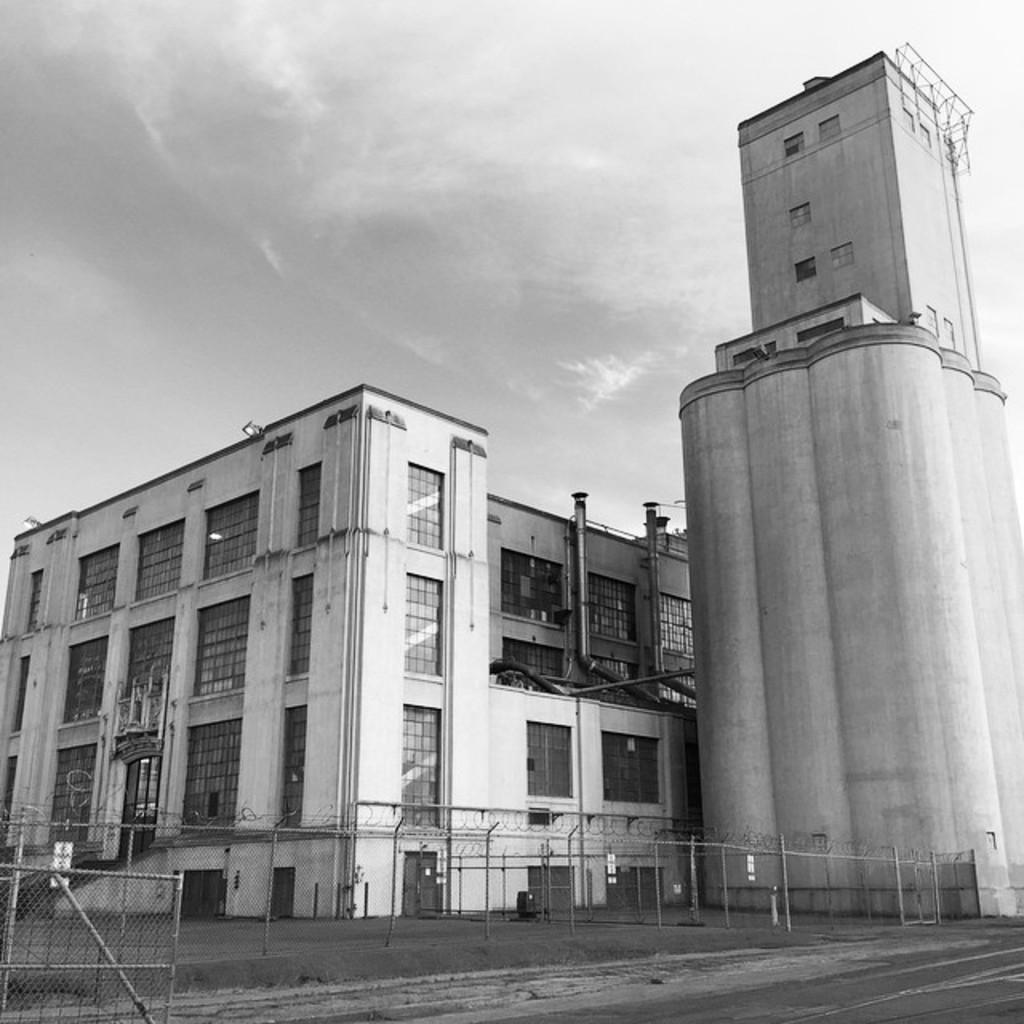Please provide a concise description of this image. In this image I can see the ground, the metal fencing and few huge buildings. I can see few pipes to the buildings and in the background I can see the sky. 